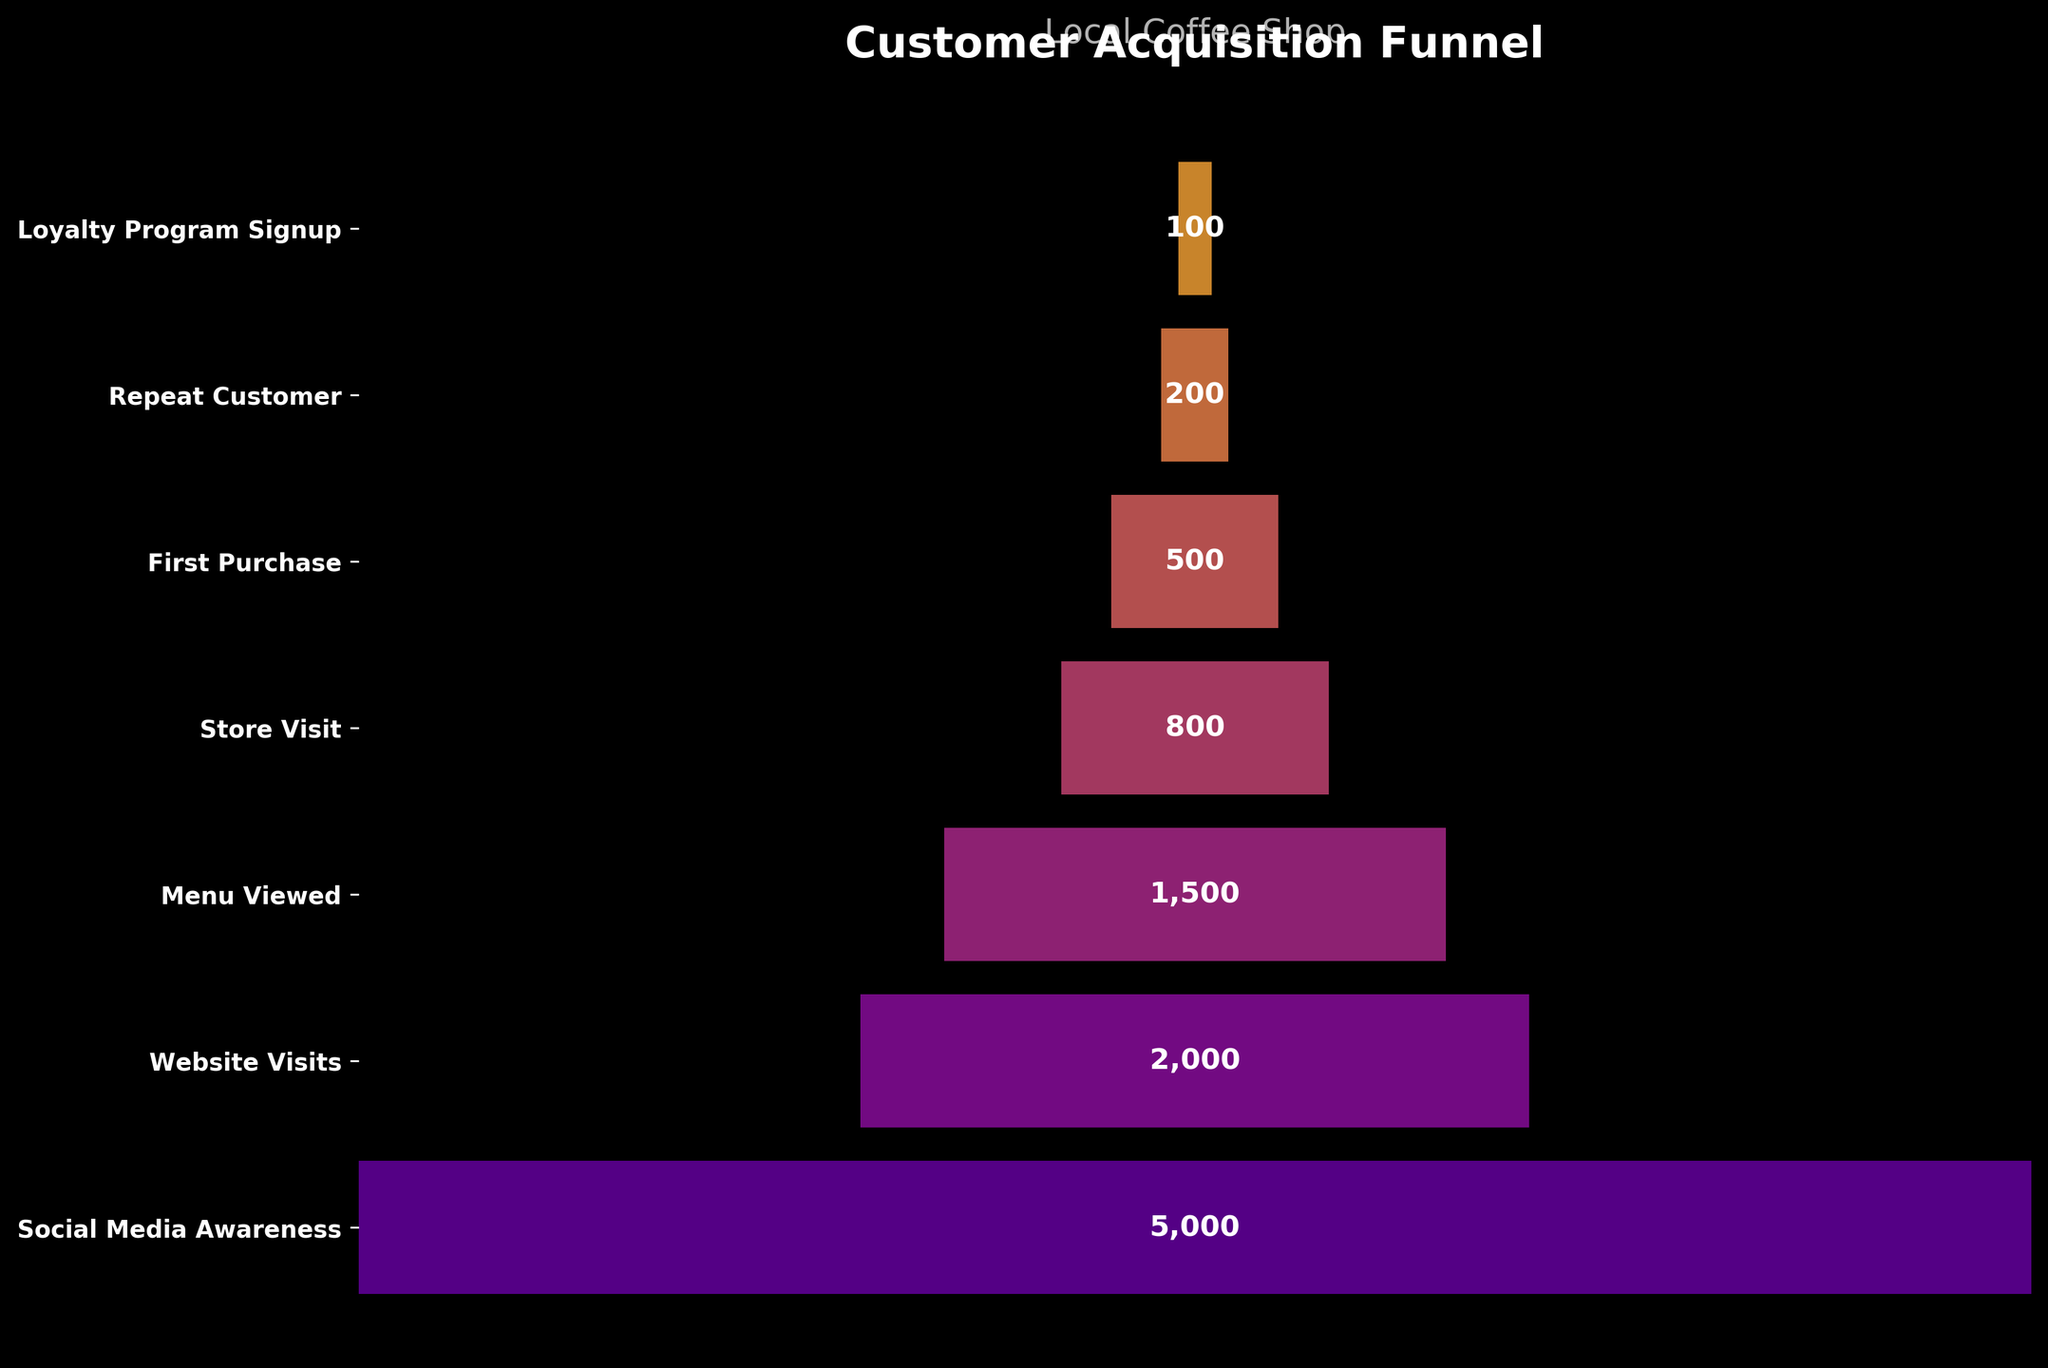What is the title of the funnel chart? The title of the funnel chart is displayed at the top. It provides a summary of what the chart represents.
Answer: Customer Acquisition Funnel How many customer stages are there in the funnel? Count the number of stages listed along the y-axis. Each stage is a different level in the customer acquisition process.
Answer: 7 How many customers made their first purchase? Look at the bar labeled "First Purchase" and read the customer number displayed in the middle of the bar.
Answer: 500 What is the difference in the number of customers between the "Website Visits" and "Menu Viewed" stages? Subtract the number of customers at the "Menu Viewed" stage from the number of customers at the "Website Visits" stage: 2000 - 1500.
Answer: 500 Which stage has the fewest customers? Identify the bar with the smallest number displayed. This indicates the stage with the fewest customers.
Answer: Loyalty Program Signup By how much do the number of "Social Media Awareness" customers exceed the number of "Store Visit" customers? Subtract the number of customers at the "Store Visit" stage from the number of customers at the "Social Media Awareness" stage: 5000 - 800.
Answer: 4200 Is the number of repeat customers greater than half of the number of customers who made their first purchase? Compare the number of repeat customers (200) with half the number of first purchase customers (500 / 2 = 250).
Answer: No What percentage of customers moved from "Menu Viewed" to "Store Visit"? Calculate the percentage by dividing the number of "Store Visit" customers by the number of "Menu Viewed" customers and multiplying by 100: (800 / 1500) * 100%.
Answer: 53.33% What is the average number of customers across all stages? Sum the number of customers for all stages and divide by the number of stages: (5000 + 2000 + 1500 + 800 + 500 + 200 + 100) / 7.
Answer: 1300 Which stage sees the biggest drop in customer numbers compared to the previous stage? Calculate the difference in customer numbers between consecutive stages and find the largest difference: 5000-2000=3000, 2000-1500=500, 1500-800=700, 800-500=300, 500-200=300, 200-100=100.
Answer: Social Media Awareness to Website Visits (3000) 